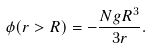<formula> <loc_0><loc_0><loc_500><loc_500>\phi ( r > R ) = - \frac { N g R ^ { 3 } } { 3 r } .</formula> 